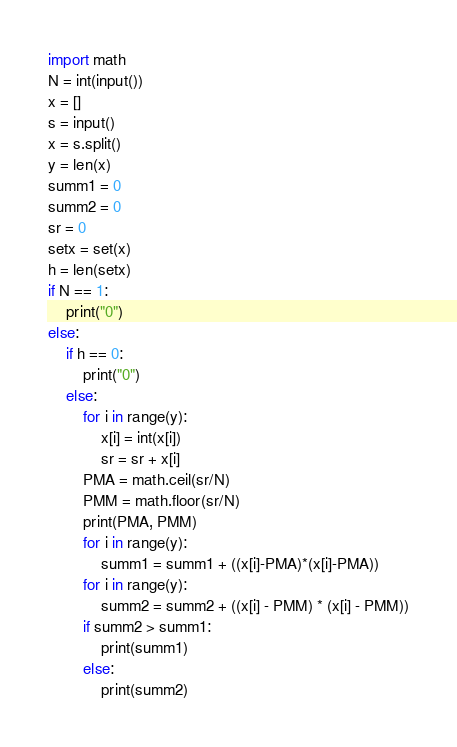Convert code to text. <code><loc_0><loc_0><loc_500><loc_500><_Python_>import math
N = int(input())
x = []
s = input()
x = s.split()
y = len(x)
summ1 = 0
summ2 = 0
sr = 0
setx = set(x)
h = len(setx)
if N == 1:
    print("0")
else:
    if h == 0:
        print("0")
    else:
        for i in range(y):
            x[i] = int(x[i])
            sr = sr + x[i]
        PMA = math.ceil(sr/N)
        PMM = math.floor(sr/N)
        print(PMA, PMM)
        for i in range(y):
            summ1 = summ1 + ((x[i]-PMA)*(x[i]-PMA))
        for i in range(y):
            summ2 = summ2 + ((x[i] - PMM) * (x[i] - PMM))
        if summ2 > summ1:
            print(summ1)
        else:
            print(summ2)
</code> 